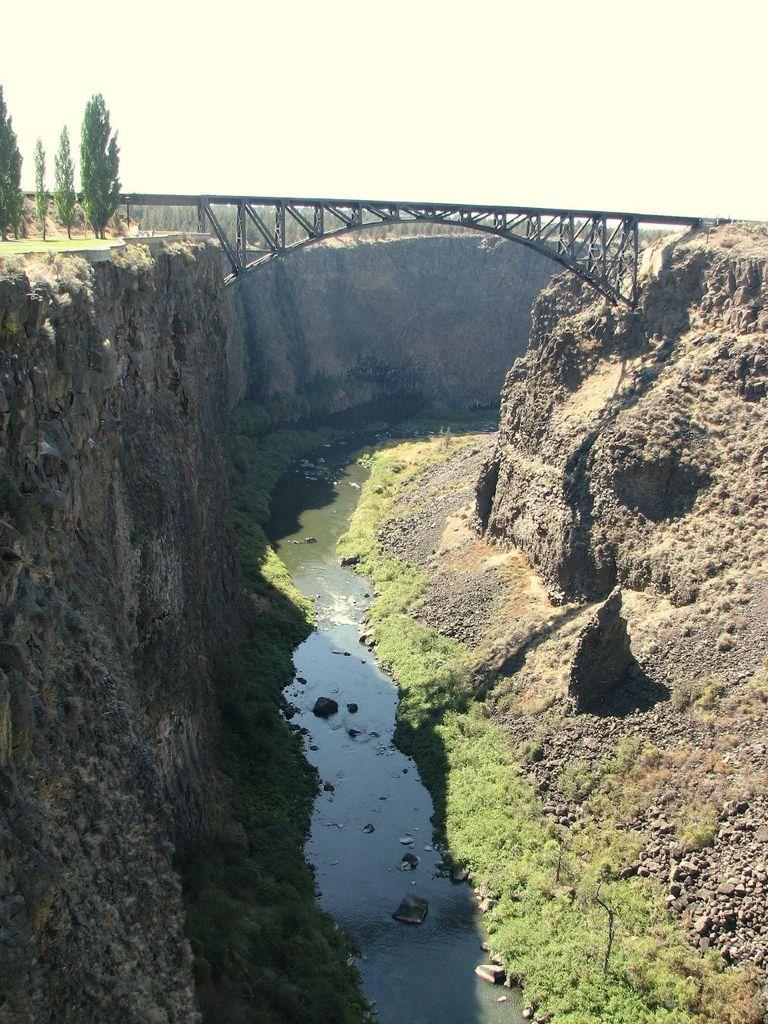What type of scene is shown in the image? The image depicts a beautiful scene of nature. Can you describe the landscape in the image? There are two mountains on both sides of the image, and a small river or lake in the middle. What type of acoustics can be heard from the cork in the image? There is no cork present in the image, and therefore no acoustics can be heard from it. 